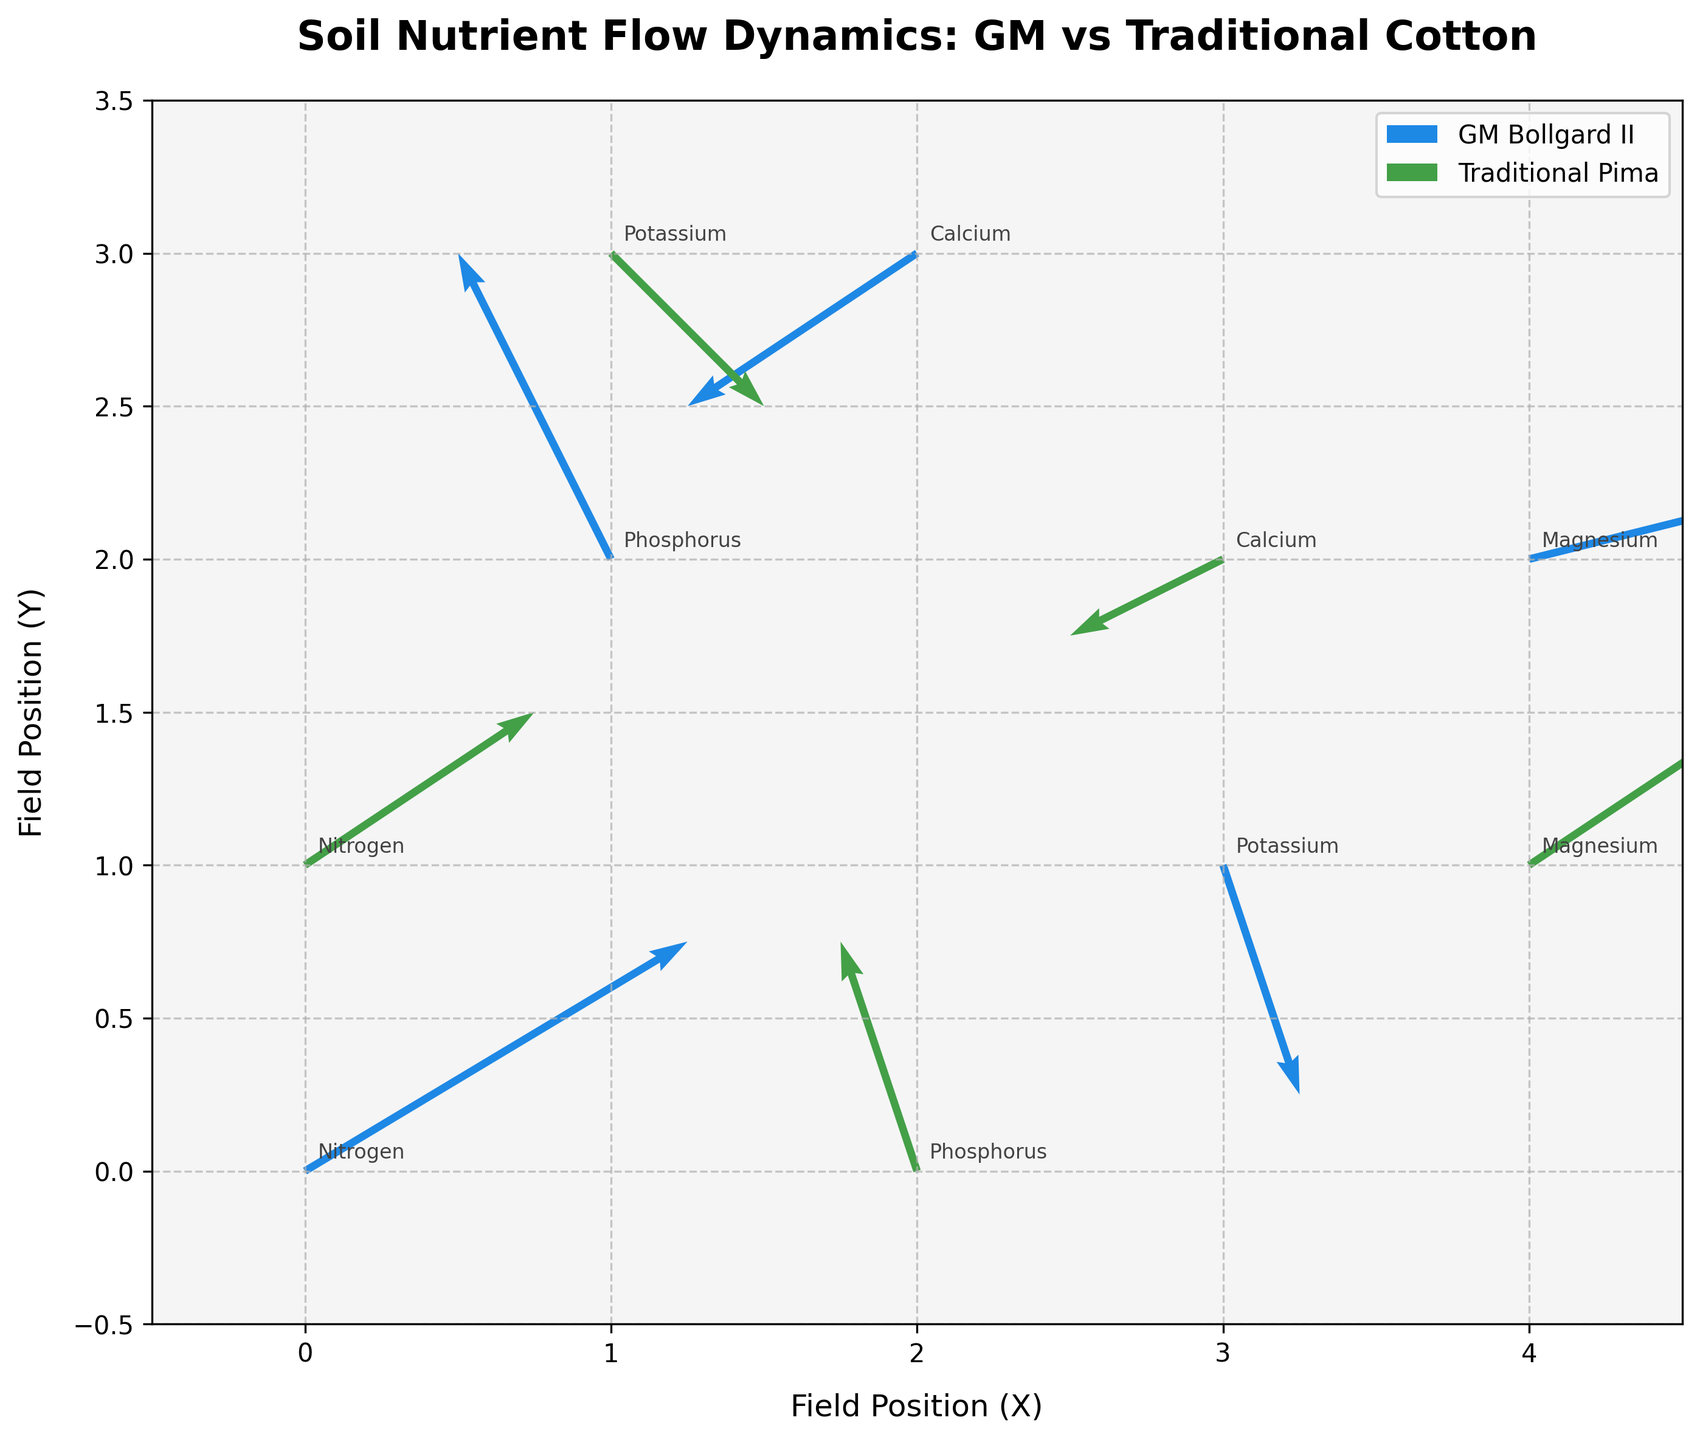How many nutrients are tracked in the plot? There are labels for nutrients in different positions on the plot. By counting these labels, we can see there are five distinct nutrients tracked.
Answer: 5 What nutrient is positioned at (0,0) on the field? By looking at the plot, you can see that the label at position (0,0) is “Nitrogen.”
Answer: Nitrogen Which strain shows a greater movement flow for Nitrogen? There are arrows depicting the movement flows for each strain. Nitrogen for the GM Bollgard II has an arrow with components (0.5, 0.3), while the Traditional Pima has an arrow with components (0.3, 0.2). By comparing the magnitudes, \(\sqrt{0.5^2 + 0.3^2} \approx 0.58 \) for GM vs. \(\sqrt{0.3^2 + 0.2^2} \approx 0.36\) for Traditional.
Answer: GM Bollgard II What direction is the flow of Calcium for the GM Bollgard II strain? By examining the arrow direction for Calcium at (2, 3), we see that the arrow points towards the lower-left direction (downward and leftward with components -0.3, -0.2).
Answer: Downward-left Compare the magnitude of the Phosphorus flow between the two strains. Which one is larger? For GM Bollgard II, the components of the Phosphorus flow are (-0.2, 0.4), leading to a magnitude of \(\sqrt{(-0.2)^2 + 0.4^2} \approx 0.45 \). For Traditional Pima, the components are (-0.1, 0.3), leading to a magnitude of \(\sqrt{(-0.1)^2 + 0.3^2} \approx 0.32 \).
Answer: GM Bollgard II Which strain has a nutrient flow directed upwards at position (2, 0)? At position (2, 0), there is only one arrow pointing upward. According to the plot information, this is a Traditional Pima strain.
Answer: Traditional Pima What is the average direction of flow for Magnesium within GM Bollgard II? The components for Magnesium within GM Bollgard II are (0.4, 0.1). These components together give an average upward-right direction.
Answer: Upward-right How many nutrients for the Traditional Pima strain have downward flows? By looking at the arrows for Traditional Pima strain in the plot, we see that both Potassium and Calcium have arrows pointing downward.
Answer: 2 What is the position of the Potassium flow for the GM Bollgard II strain? By referring to the plot, the arrow representing Potassium flow for the GM Bollgard II strain is at the coordinates (3, 1).
Answer: (3, 1) 